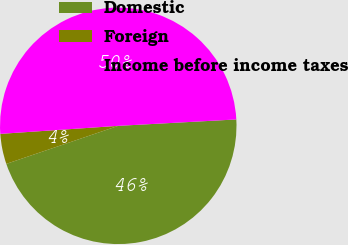Convert chart to OTSL. <chart><loc_0><loc_0><loc_500><loc_500><pie_chart><fcel>Domestic<fcel>Foreign<fcel>Income before income taxes<nl><fcel>45.65%<fcel>4.13%<fcel>50.22%<nl></chart> 